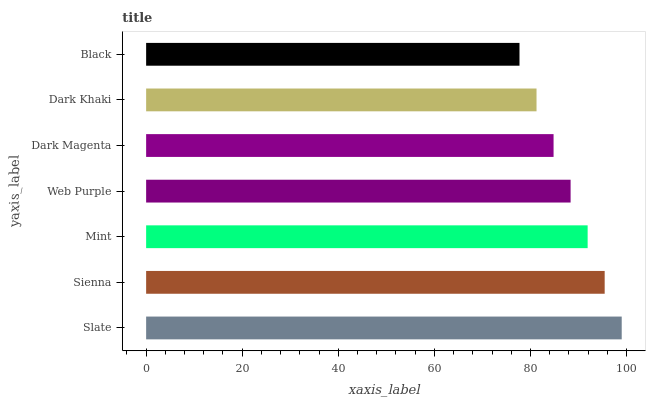Is Black the minimum?
Answer yes or no. Yes. Is Slate the maximum?
Answer yes or no. Yes. Is Sienna the minimum?
Answer yes or no. No. Is Sienna the maximum?
Answer yes or no. No. Is Slate greater than Sienna?
Answer yes or no. Yes. Is Sienna less than Slate?
Answer yes or no. Yes. Is Sienna greater than Slate?
Answer yes or no. No. Is Slate less than Sienna?
Answer yes or no. No. Is Web Purple the high median?
Answer yes or no. Yes. Is Web Purple the low median?
Answer yes or no. Yes. Is Slate the high median?
Answer yes or no. No. Is Slate the low median?
Answer yes or no. No. 